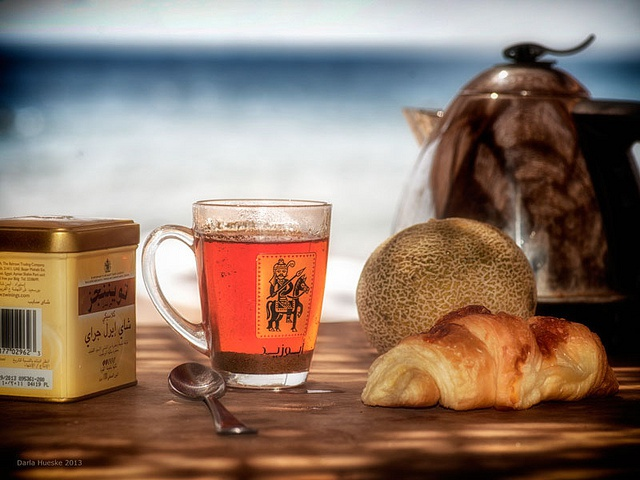Describe the objects in this image and their specific colors. I can see dining table in purple, maroon, black, and brown tones, cup in purple, red, white, and maroon tones, and spoon in purple, maroon, black, and brown tones in this image. 